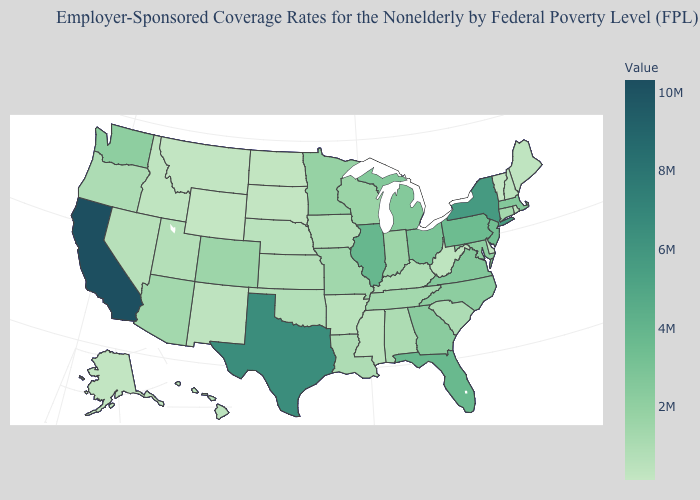Which states have the lowest value in the USA?
Quick response, please. Wyoming. Which states have the lowest value in the USA?
Be succinct. Wyoming. Among the states that border Kentucky , which have the highest value?
Quick response, please. Illinois. Which states have the lowest value in the USA?
Be succinct. Wyoming. Which states have the lowest value in the USA?
Short answer required. Wyoming. Among the states that border Michigan , which have the highest value?
Short answer required. Ohio. 